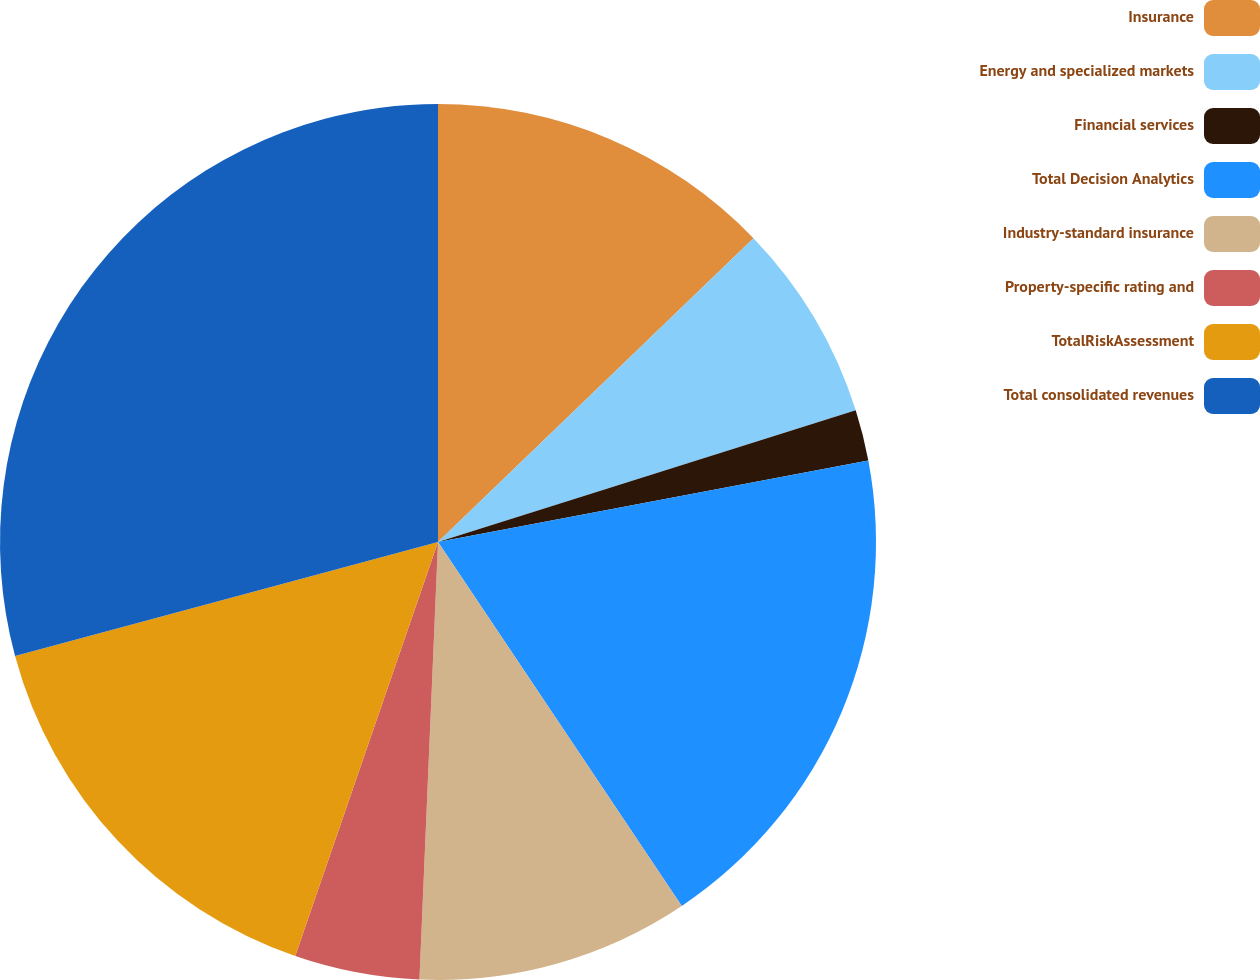Convert chart to OTSL. <chart><loc_0><loc_0><loc_500><loc_500><pie_chart><fcel>Insurance<fcel>Energy and specialized markets<fcel>Financial services<fcel>Total Decision Analytics<fcel>Industry-standard insurance<fcel>Property-specific rating and<fcel>TotalRiskAssessment<fcel>Total consolidated revenues<nl><fcel>12.8%<fcel>7.34%<fcel>1.88%<fcel>18.59%<fcel>10.07%<fcel>4.61%<fcel>15.53%<fcel>29.19%<nl></chart> 